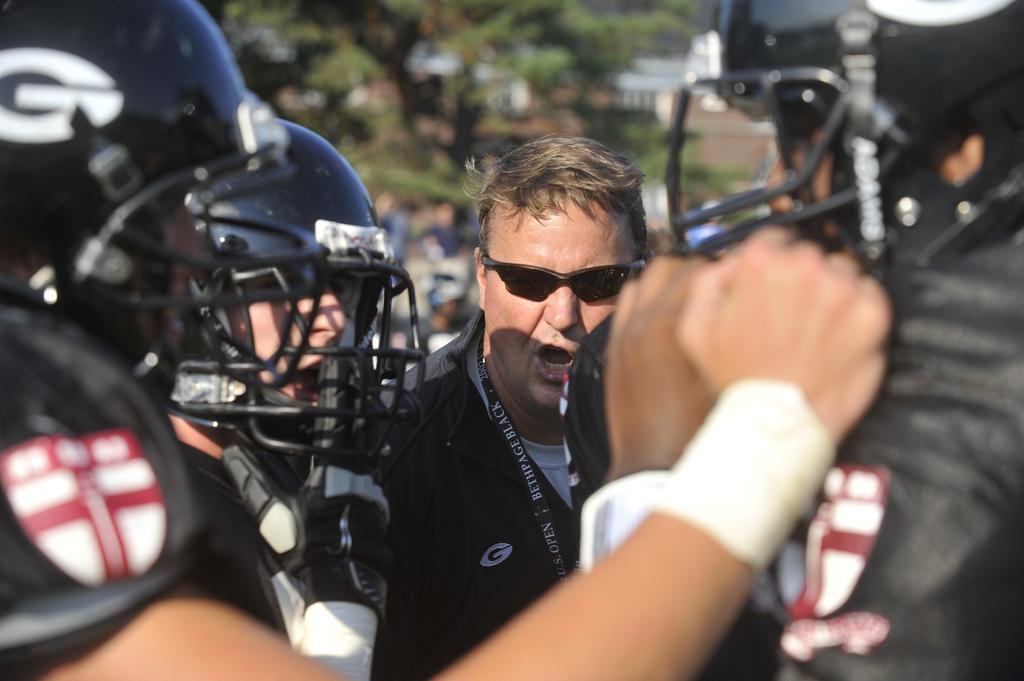In one or two sentences, can you explain what this image depicts? In this image in the foreground I can see persons and few persons wearing helmet and I can see one person wearing spectacle and at the top I can see trees. 